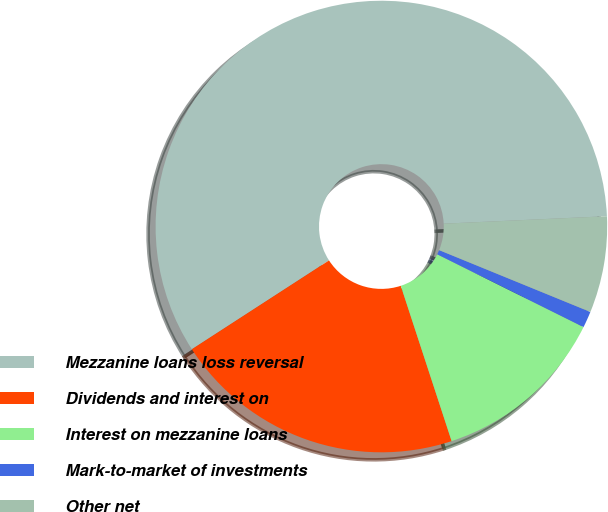Convert chart. <chart><loc_0><loc_0><loc_500><loc_500><pie_chart><fcel>Mezzanine loans loss reversal<fcel>Dividends and interest on<fcel>Interest on mezzanine loans<fcel>Mark-to-market of investments<fcel>Other net<nl><fcel>58.42%<fcel>20.89%<fcel>12.62%<fcel>1.17%<fcel>6.9%<nl></chart> 